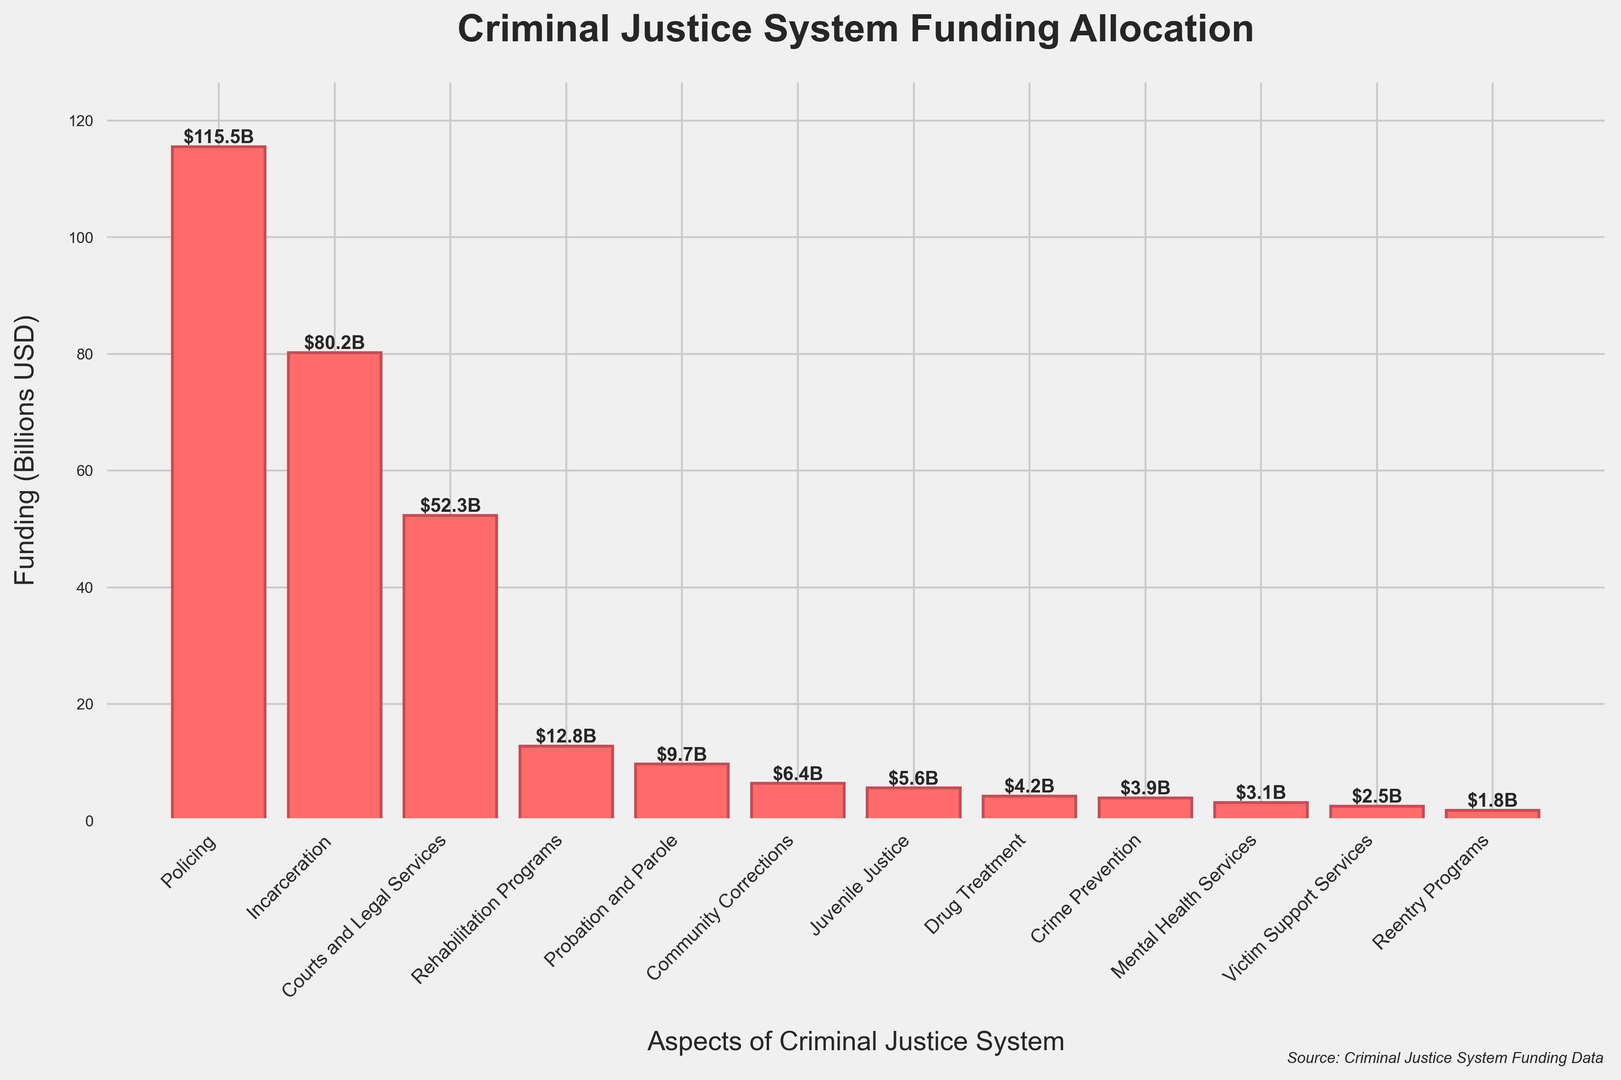Which aspect of the criminal justice system receives the most funding? The bar chart shows that the "Policing" aspect has the tallest bar, indicating it receives the highest funding.
Answer: Policing How much more funding does Incarceration receive compared to Rehabilitation Programs? Incarceration receives $80.2 billion, and Rehabilitation Programs receive $12.8 billion. The difference is $80.2 billion - $12.8 billion = $67.4 billion.
Answer: $67.4 billion What is the total funding allocated to Juvenile Justice and Crime Prevention combined? Juvenile Justice receives $5.6 billion, and Crime Prevention receives $3.9 billion. Combined, it's $5.6 billion + $3.9 billion = $9.5 billion.
Answer: $9.5 billion Which has a higher funding allocation: Probation and Parole or Drug Treatment? The bars for Probation and Parole and Drug Treatment show that Probation and Parole has $9.7 billion while Drug Treatment has $4.2 billion. Probation and Parole is higher.
Answer: Probation and Parole Among Victim Support Services, Mental Health Services, and Reentry Programs, which has the lowest funding? The bars for Victim Support Services, Mental Health Services, and Reentry Programs show that Reentry Programs have the lowest funding at $1.8 billion.
Answer: Reentry Programs What is the average funding allocated to Courts and Legal Services, Community Corrections, and Mental Health Services? Courts and Legal Services receive $52.3 billion, Community Corrections receive $6.4 billion, and Mental Health Services receive $3.1 billion. The average is ($52.3 + $6.4 + $3.1)/3 = $61.8/3 ≈ $20.6 billion.
Answer: $20.6 billion How does the funding for Crime Prevention compare to that for Community Corrections? Community Corrections receive $6.4 billion while Crime Prevention receives $3.9 billion. Community Corrections receive more funding.
Answer: Community Corrections What's the difference in funding between the highest and lowest funded aspects? The highest funding is for Policing at $115.5 billion, and the lowest is Reentry Programs at $1.8 billion. The difference is $115.5 billion - $1.8 billion = $113.7 billion.
Answer: $113.7 billion If the funding for Victim Support Services were doubled, where would it rank in the chart? The current funding for Victim Support Services is $2.5 billion. If doubled, it would be $5.0 billion. This would put it between Juvenile Justice ($5.6 billion) and Probation and Parole ($9.7 billion), making it the 6th highest.
Answer: 6th highest 